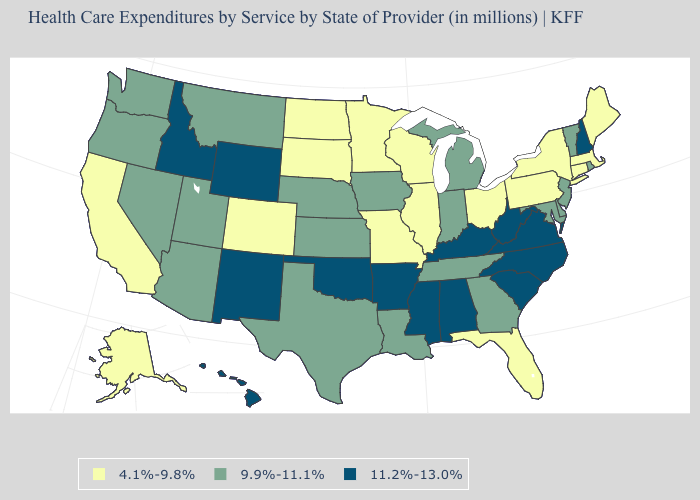What is the value of Ohio?
Quick response, please. 4.1%-9.8%. Among the states that border West Virginia , which have the lowest value?
Concise answer only. Ohio, Pennsylvania. What is the value of Indiana?
Short answer required. 9.9%-11.1%. Name the states that have a value in the range 4.1%-9.8%?
Keep it brief. Alaska, California, Colorado, Connecticut, Florida, Illinois, Maine, Massachusetts, Minnesota, Missouri, New York, North Dakota, Ohio, Pennsylvania, South Dakota, Wisconsin. What is the value of Maryland?
Be succinct. 9.9%-11.1%. Does North Dakota have the lowest value in the MidWest?
Write a very short answer. Yes. Name the states that have a value in the range 9.9%-11.1%?
Concise answer only. Arizona, Delaware, Georgia, Indiana, Iowa, Kansas, Louisiana, Maryland, Michigan, Montana, Nebraska, Nevada, New Jersey, Oregon, Rhode Island, Tennessee, Texas, Utah, Vermont, Washington. Does New York have the same value as California?
Keep it brief. Yes. Name the states that have a value in the range 4.1%-9.8%?
Concise answer only. Alaska, California, Colorado, Connecticut, Florida, Illinois, Maine, Massachusetts, Minnesota, Missouri, New York, North Dakota, Ohio, Pennsylvania, South Dakota, Wisconsin. What is the highest value in the MidWest ?
Answer briefly. 9.9%-11.1%. Which states have the lowest value in the MidWest?
Be succinct. Illinois, Minnesota, Missouri, North Dakota, Ohio, South Dakota, Wisconsin. Which states have the highest value in the USA?
Short answer required. Alabama, Arkansas, Hawaii, Idaho, Kentucky, Mississippi, New Hampshire, New Mexico, North Carolina, Oklahoma, South Carolina, Virginia, West Virginia, Wyoming. Does Delaware have the same value as Oklahoma?
Answer briefly. No. What is the value of Idaho?
Write a very short answer. 11.2%-13.0%. Does the first symbol in the legend represent the smallest category?
Concise answer only. Yes. 